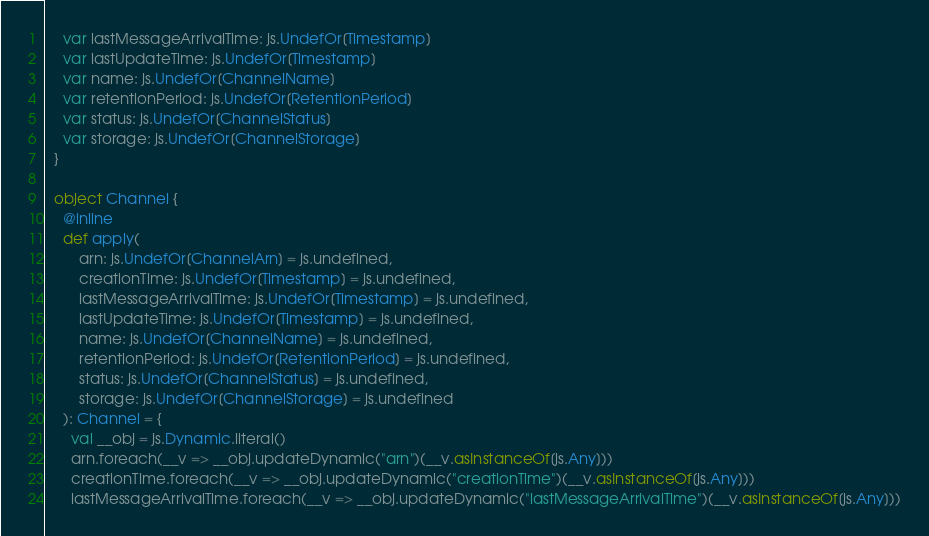Convert code to text. <code><loc_0><loc_0><loc_500><loc_500><_Scala_>    var lastMessageArrivalTime: js.UndefOr[Timestamp]
    var lastUpdateTime: js.UndefOr[Timestamp]
    var name: js.UndefOr[ChannelName]
    var retentionPeriod: js.UndefOr[RetentionPeriod]
    var status: js.UndefOr[ChannelStatus]
    var storage: js.UndefOr[ChannelStorage]
  }

  object Channel {
    @inline
    def apply(
        arn: js.UndefOr[ChannelArn] = js.undefined,
        creationTime: js.UndefOr[Timestamp] = js.undefined,
        lastMessageArrivalTime: js.UndefOr[Timestamp] = js.undefined,
        lastUpdateTime: js.UndefOr[Timestamp] = js.undefined,
        name: js.UndefOr[ChannelName] = js.undefined,
        retentionPeriod: js.UndefOr[RetentionPeriod] = js.undefined,
        status: js.UndefOr[ChannelStatus] = js.undefined,
        storage: js.UndefOr[ChannelStorage] = js.undefined
    ): Channel = {
      val __obj = js.Dynamic.literal()
      arn.foreach(__v => __obj.updateDynamic("arn")(__v.asInstanceOf[js.Any]))
      creationTime.foreach(__v => __obj.updateDynamic("creationTime")(__v.asInstanceOf[js.Any]))
      lastMessageArrivalTime.foreach(__v => __obj.updateDynamic("lastMessageArrivalTime")(__v.asInstanceOf[js.Any]))</code> 